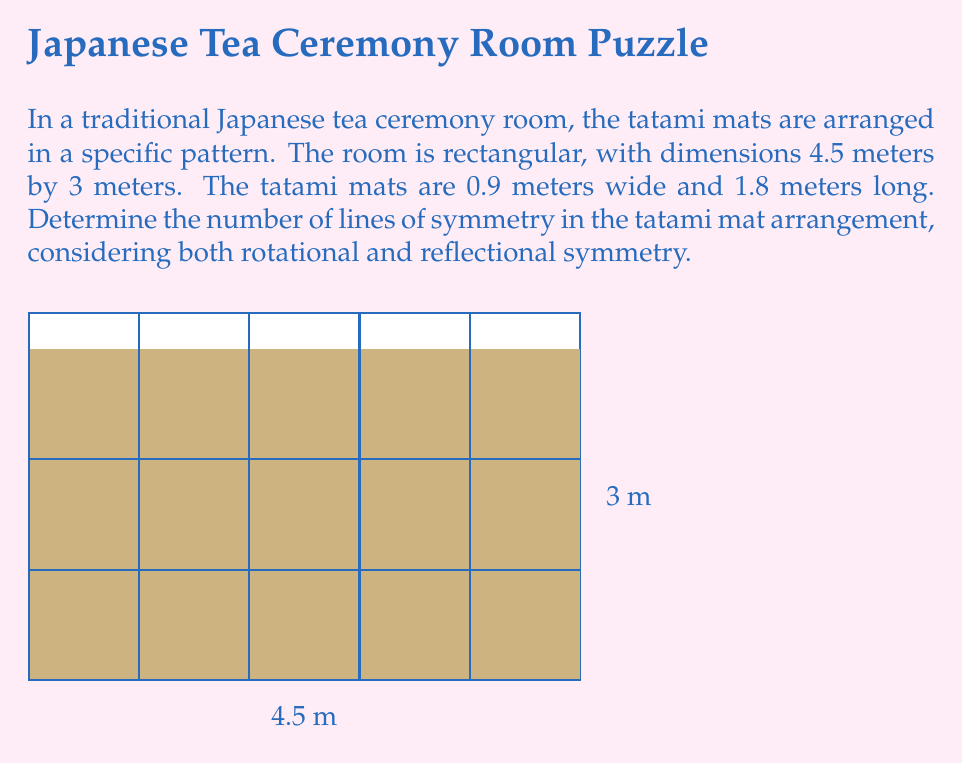Can you solve this math problem? Let's approach this step-by-step:

1) First, we need to calculate how many tatami mats fit in each direction:
   - Length: $4.5 \text{ m} \div 1.8 \text{ m} = 2.5$ mats
   - Width: $3 \text{ m} \div 0.9 \text{ m} = 3.33$ mats

2) This means we have a 2.5 x 3.33 arrangement of mats, which can be simplified to a 5 x 6.67 arrangement if we consider half-mats.

3) Now, let's consider the symmetry:

   a) Rotational symmetry:
      - The pattern has 180° rotational symmetry (2-fold symmetry).

   b) Reflectional symmetry:
      - Vertical line of symmetry: There is one vertical line of symmetry down the center of the room.
      - Horizontal line of symmetry: There is one horizontal line of symmetry across the center of the room.

4) Counting the lines of symmetry:
   - 1 vertical line
   - 1 horizontal line
   - The center point (which represents the 180° rotational symmetry) is not counted as a separate line of symmetry.

5) Therefore, the total number of lines of symmetry is 2.

This symmetrical arrangement in the tea ceremony room reflects the balance and harmony central to Zen philosophy, aligning with the persona of a Zen meditation practitioner.
Answer: 2 lines of symmetry 